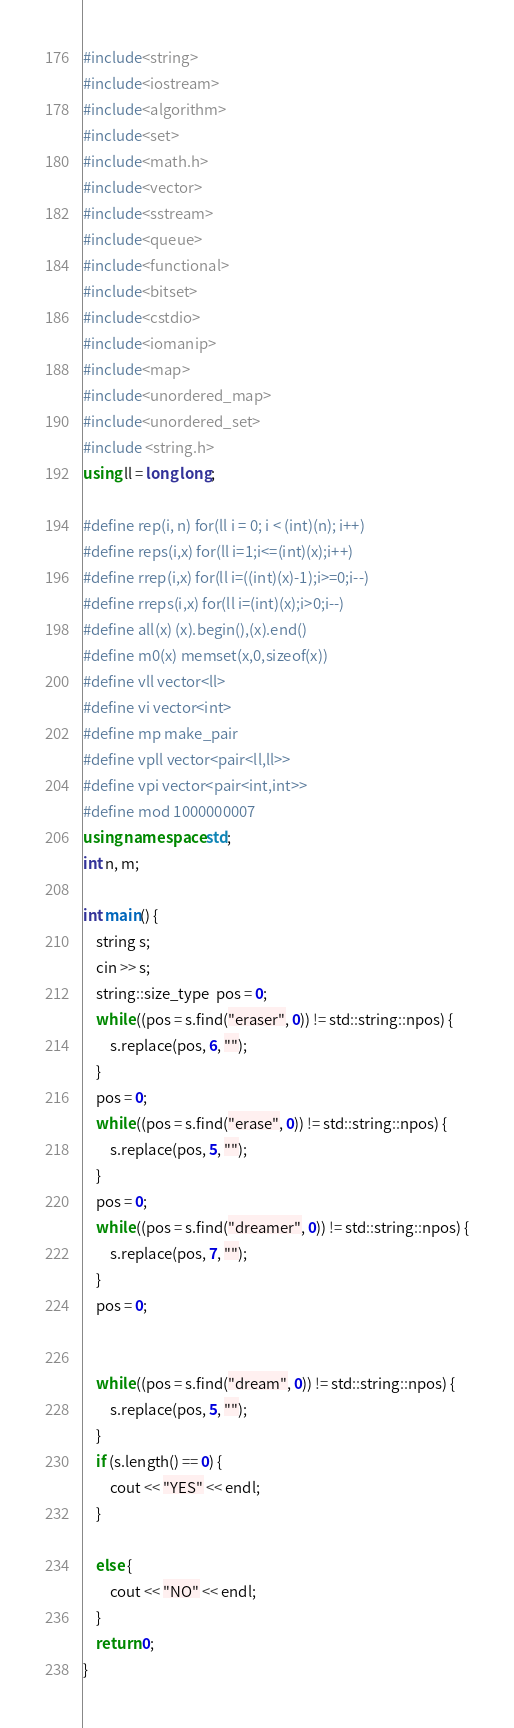<code> <loc_0><loc_0><loc_500><loc_500><_C++_>#include<string>
#include<iostream>
#include<algorithm>
#include<set>
#include<math.h>
#include<vector>
#include<sstream>
#include<queue>
#include<functional>
#include<bitset>
#include<cstdio>
#include<iomanip>
#include<map>
#include<unordered_map>
#include<unordered_set>
#include <string.h>
using ll = long long;

#define rep(i, n) for(ll i = 0; i < (int)(n); i++)
#define reps(i,x) for(ll i=1;i<=(int)(x);i++)
#define rrep(i,x) for(ll i=((int)(x)-1);i>=0;i--)
#define rreps(i,x) for(ll i=(int)(x);i>0;i--)
#define all(x) (x).begin(),(x).end()
#define m0(x) memset(x,0,sizeof(x))
#define vll vector<ll>
#define vi vector<int>
#define mp make_pair
#define vpll vector<pair<ll,ll>>
#define vpi vector<pair<int,int>>
#define mod 1000000007 
using namespace std;
int n, m;

int main() {
	string s;
	cin >> s;
	string::size_type  pos = 0;
	while ((pos = s.find("eraser", 0)) != std::string::npos) {
		s.replace(pos, 6, "");
	}
	pos = 0;
	while ((pos = s.find("erase", 0)) != std::string::npos) {
		s.replace(pos, 5, "");
	}
	pos = 0;
	while ((pos = s.find("dreamer", 0)) != std::string::npos) {
		s.replace(pos, 7, "");
	}
	pos = 0;


	while ((pos = s.find("dream", 0)) != std::string::npos) {
		s.replace(pos, 5, "");
	}
	if (s.length() == 0) {
		cout << "YES" << endl;
	}

	else {
		cout << "NO" << endl;
	}
	return 0;
}</code> 